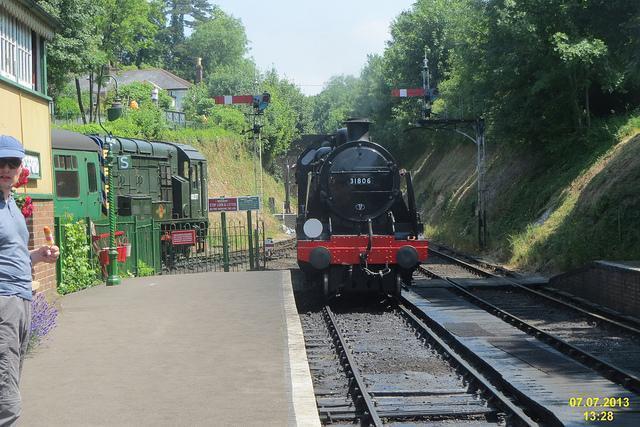What sound do people say the item on the right makes?
From the following four choices, select the correct answer to address the question.
Options: Meow, moo, choo choo, woof. Choo choo. 